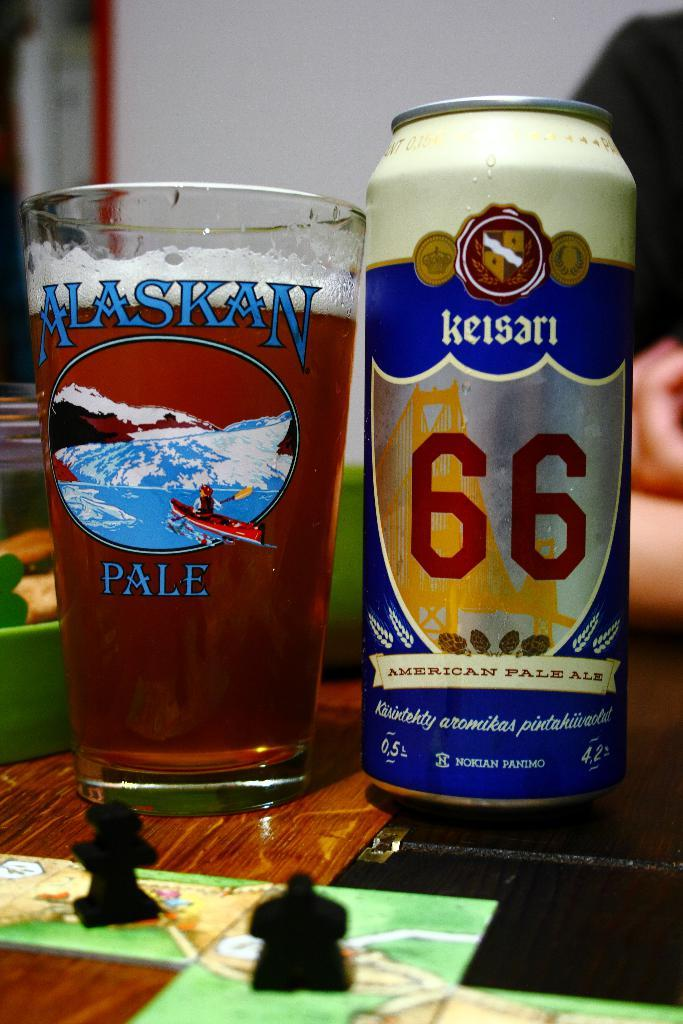Provide a one-sentence caption for the provided image. A can of Keisari beer is in an Alaskan pale glass. 